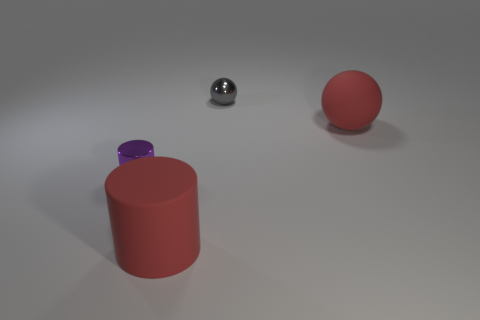What number of other objects are the same color as the matte ball? One object, which is the cylinder, shares the same red color as the matte ball. 